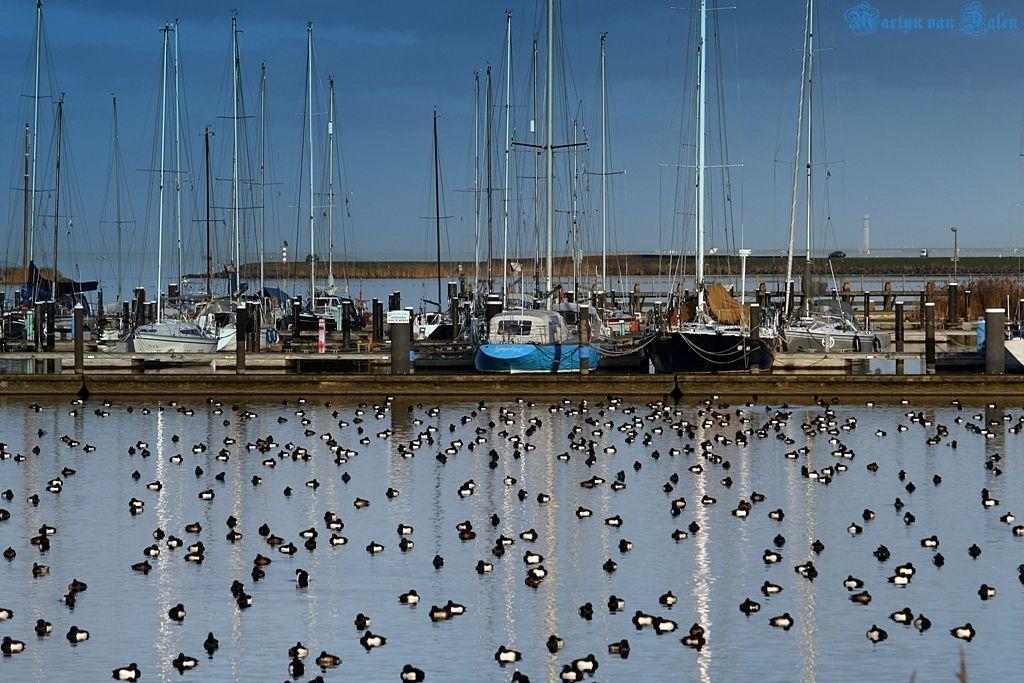How many visible blue boats are there?
Give a very brief answer. 1. 